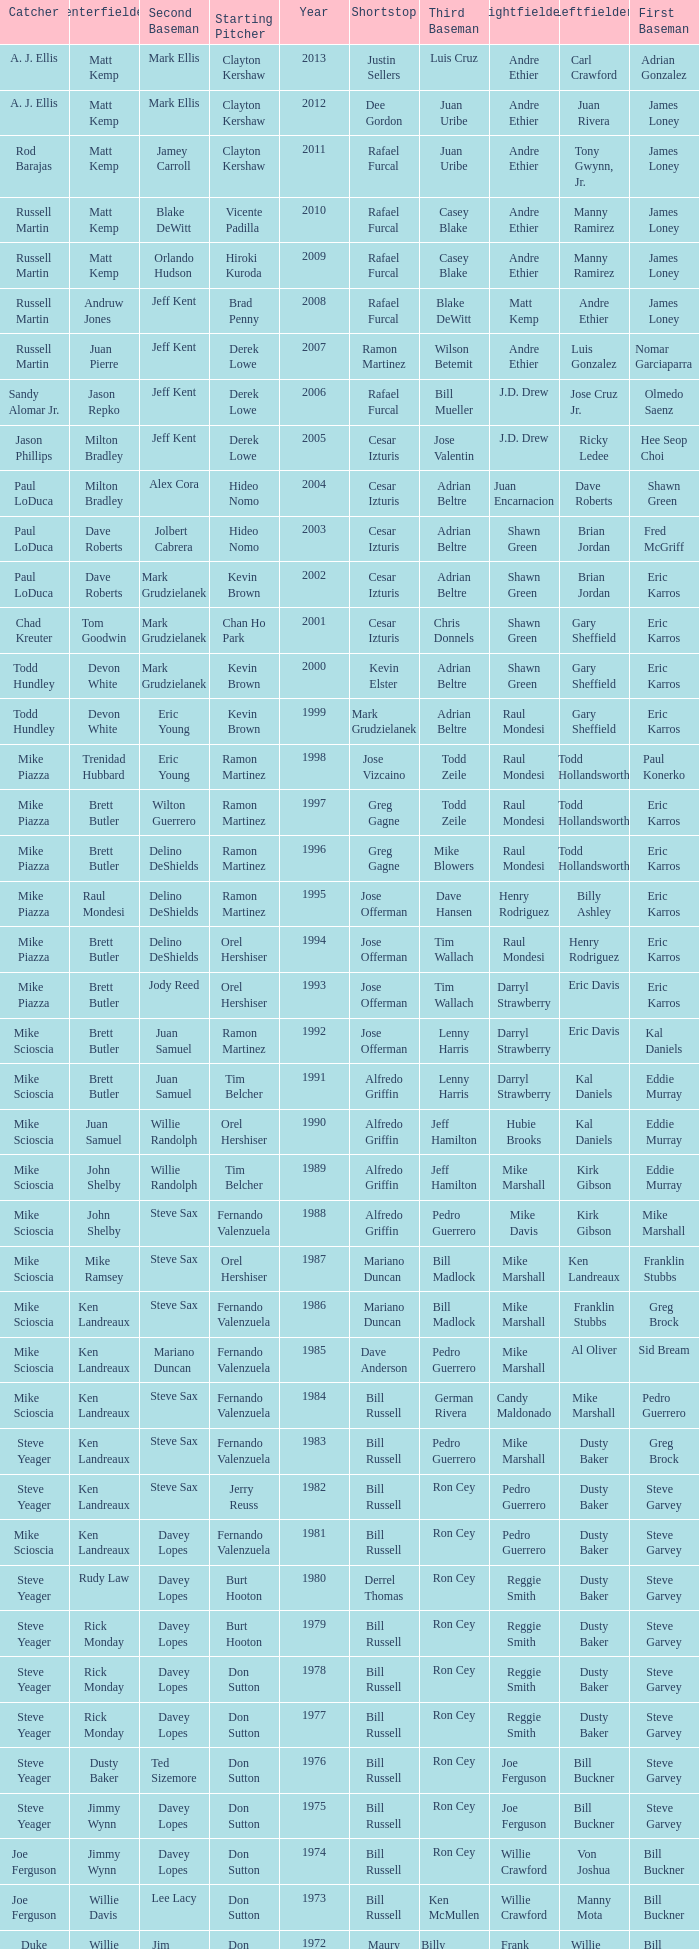Who was the RF when the SP was vicente padilla? Andre Ethier. 